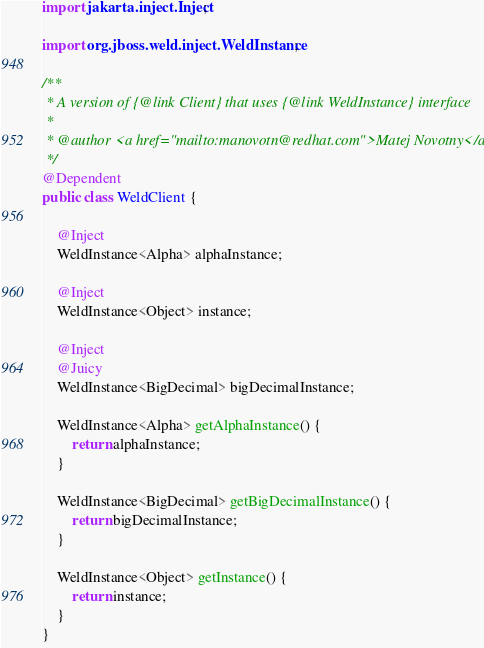<code> <loc_0><loc_0><loc_500><loc_500><_Java_>import jakarta.inject.Inject;

import org.jboss.weld.inject.WeldInstance;

/**
 * A version of {@link Client} that uses {@link WeldInstance} interface
 *
 * @author <a href="mailto:manovotn@redhat.com">Matej Novotny</a>
 */
@Dependent
public class WeldClient {

    @Inject
    WeldInstance<Alpha> alphaInstance;

    @Inject
    WeldInstance<Object> instance;

    @Inject
    @Juicy
    WeldInstance<BigDecimal> bigDecimalInstance;

    WeldInstance<Alpha> getAlphaInstance() {
        return alphaInstance;
    }

    WeldInstance<BigDecimal> getBigDecimalInstance() {
        return bigDecimalInstance;
    }

    WeldInstance<Object> getInstance() {
        return instance;
    }
}
</code> 